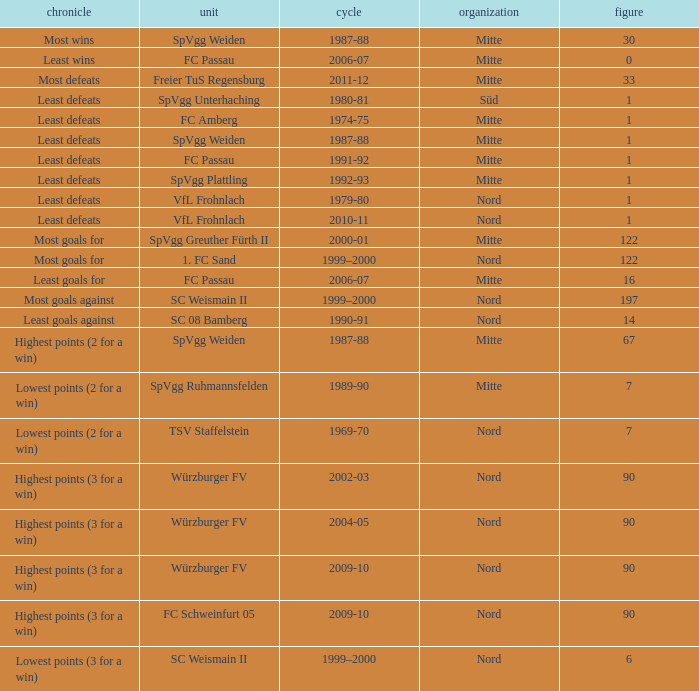What season has a number less than 90, Mitte as the league and spvgg ruhmannsfelden as the team? 1989-90. 